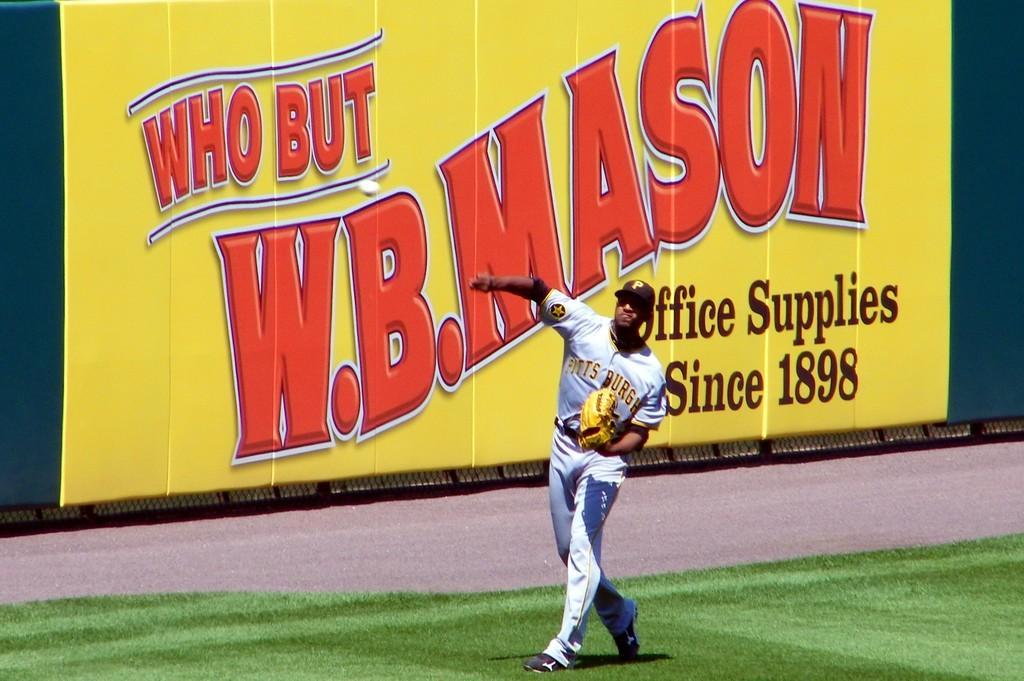<image>
Create a compact narrative representing the image presented. A Pittsburgh player stands in front of an ad for WB Mason office supplies. 